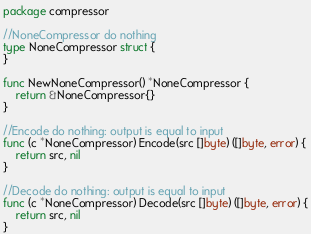Convert code to text. <code><loc_0><loc_0><loc_500><loc_500><_Go_>package compressor

//NoneCompressor do nothing
type NoneCompressor struct {
}

func NewNoneCompressor() *NoneCompressor {
	return &NoneCompressor{}
}

//Encode do nothing: output is equal to input
func (c *NoneCompressor) Encode(src []byte) ([]byte, error) {
	return src, nil
}

//Decode do nothing: output is equal to input
func (c *NoneCompressor) Decode(src []byte) ([]byte, error) {
	return src, nil
}
</code> 